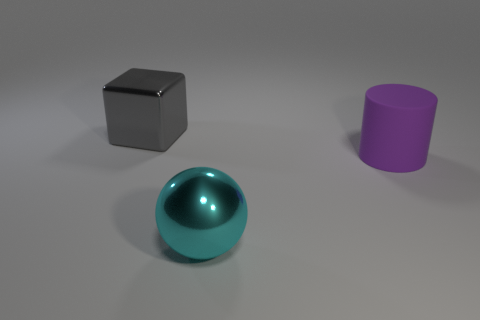Is there anything else that is made of the same material as the cylinder?
Provide a succinct answer. No. Do the gray block and the cylinder have the same material?
Offer a very short reply. No. There is a large object that is in front of the big thing right of the large cyan metallic thing; what shape is it?
Ensure brevity in your answer.  Sphere. There is a large thing that is to the left of the cyan metal thing; how many large cyan metallic balls are in front of it?
Make the answer very short. 1. What is the material of the big object that is both right of the gray shiny cube and behind the large cyan metallic sphere?
Offer a very short reply. Rubber. What shape is the purple rubber thing that is the same size as the gray shiny thing?
Offer a terse response. Cylinder. The shiny thing that is behind the metal object to the right of the shiny cube to the left of the purple cylinder is what color?
Your answer should be compact. Gray. How many objects are either shiny objects that are behind the cyan thing or large rubber things?
Your response must be concise. 2. There is a purple cylinder that is the same size as the cyan thing; what is its material?
Provide a succinct answer. Rubber. What is the object that is in front of the big purple matte cylinder on the right side of the metal object that is in front of the large gray metallic block made of?
Your response must be concise. Metal. 